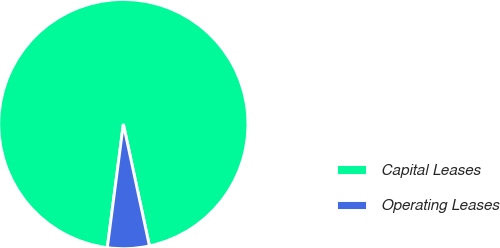<chart> <loc_0><loc_0><loc_500><loc_500><pie_chart><fcel>Capital Leases<fcel>Operating Leases<nl><fcel>94.59%<fcel>5.41%<nl></chart> 